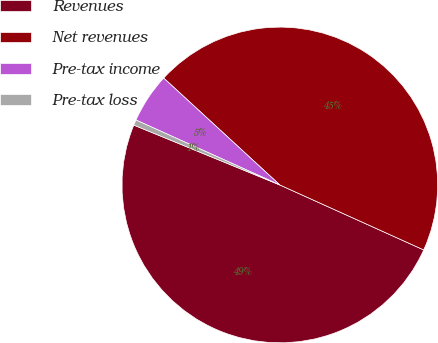Convert chart. <chart><loc_0><loc_0><loc_500><loc_500><pie_chart><fcel>Revenues<fcel>Net revenues<fcel>Pre-tax income<fcel>Pre-tax loss<nl><fcel>49.44%<fcel>44.91%<fcel>5.09%<fcel>0.56%<nl></chart> 